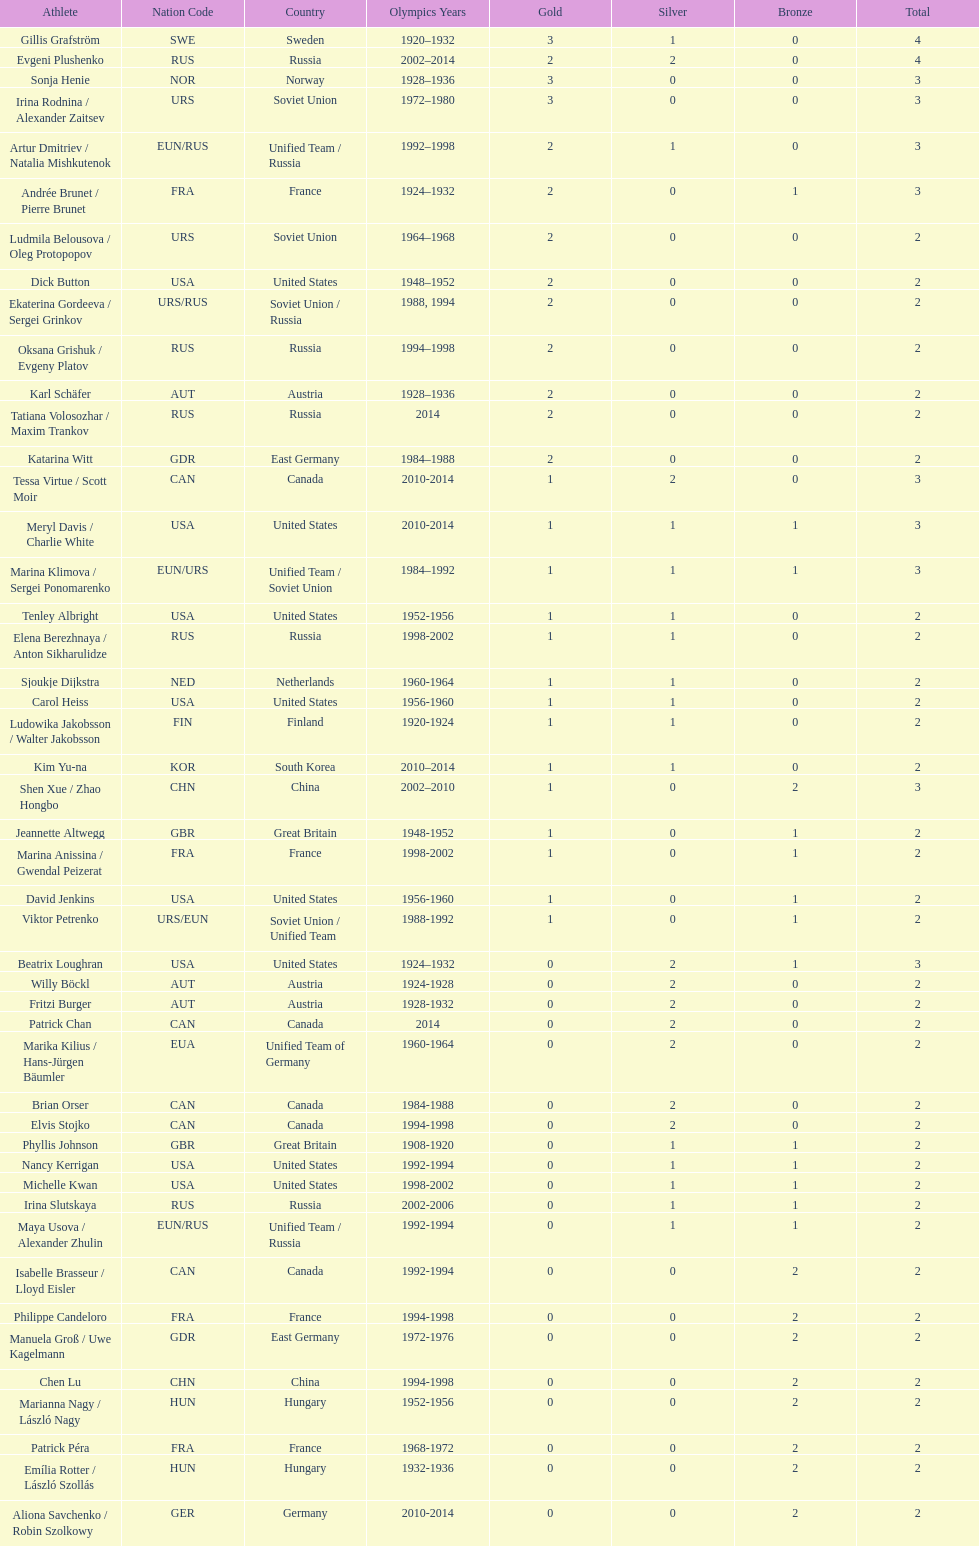What was the greatest number of gold medals won by a single athlete? 3. Could you parse the entire table? {'header': ['Athlete', 'Nation Code', 'Country', 'Olympics Years', 'Gold', 'Silver', 'Bronze', 'Total'], 'rows': [['Gillis Grafström', 'SWE', 'Sweden', '1920–1932', '3', '1', '0', '4'], ['Evgeni Plushenko', 'RUS', 'Russia', '2002–2014', '2', '2', '0', '4'], ['Sonja Henie', 'NOR', 'Norway', '1928–1936', '3', '0', '0', '3'], ['Irina Rodnina / Alexander Zaitsev', 'URS', 'Soviet Union', '1972–1980', '3', '0', '0', '3'], ['Artur Dmitriev / Natalia Mishkutenok', 'EUN/RUS', 'Unified Team / Russia', '1992–1998', '2', '1', '0', '3'], ['Andrée Brunet / Pierre Brunet', 'FRA', 'France', '1924–1932', '2', '0', '1', '3'], ['Ludmila Belousova / Oleg Protopopov', 'URS', 'Soviet Union', '1964–1968', '2', '0', '0', '2'], ['Dick Button', 'USA', 'United States', '1948–1952', '2', '0', '0', '2'], ['Ekaterina Gordeeva / Sergei Grinkov', 'URS/RUS', 'Soviet Union / Russia', '1988, 1994', '2', '0', '0', '2'], ['Oksana Grishuk / Evgeny Platov', 'RUS', 'Russia', '1994–1998', '2', '0', '0', '2'], ['Karl Schäfer', 'AUT', 'Austria', '1928–1936', '2', '0', '0', '2'], ['Tatiana Volosozhar / Maxim Trankov', 'RUS', 'Russia', '2014', '2', '0', '0', '2'], ['Katarina Witt', 'GDR', 'East Germany', '1984–1988', '2', '0', '0', '2'], ['Tessa Virtue / Scott Moir', 'CAN', 'Canada', '2010-2014', '1', '2', '0', '3'], ['Meryl Davis / Charlie White', 'USA', 'United States', '2010-2014', '1', '1', '1', '3'], ['Marina Klimova / Sergei Ponomarenko', 'EUN/URS', 'Unified Team / Soviet Union', '1984–1992', '1', '1', '1', '3'], ['Tenley Albright', 'USA', 'United States', '1952-1956', '1', '1', '0', '2'], ['Elena Berezhnaya / Anton Sikharulidze', 'RUS', 'Russia', '1998-2002', '1', '1', '0', '2'], ['Sjoukje Dijkstra', 'NED', 'Netherlands', '1960-1964', '1', '1', '0', '2'], ['Carol Heiss', 'USA', 'United States', '1956-1960', '1', '1', '0', '2'], ['Ludowika Jakobsson / Walter Jakobsson', 'FIN', 'Finland', '1920-1924', '1', '1', '0', '2'], ['Kim Yu-na', 'KOR', 'South Korea', '2010–2014', '1', '1', '0', '2'], ['Shen Xue / Zhao Hongbo', 'CHN', 'China', '2002–2010', '1', '0', '2', '3'], ['Jeannette Altwegg', 'GBR', 'Great Britain', '1948-1952', '1', '0', '1', '2'], ['Marina Anissina / Gwendal Peizerat', 'FRA', 'France', '1998-2002', '1', '0', '1', '2'], ['David Jenkins', 'USA', 'United States', '1956-1960', '1', '0', '1', '2'], ['Viktor Petrenko', 'URS/EUN', 'Soviet Union / Unified Team', '1988-1992', '1', '0', '1', '2'], ['Beatrix Loughran', 'USA', 'United States', '1924–1932', '0', '2', '1', '3'], ['Willy Böckl', 'AUT', 'Austria', '1924-1928', '0', '2', '0', '2'], ['Fritzi Burger', 'AUT', 'Austria', '1928-1932', '0', '2', '0', '2'], ['Patrick Chan', 'CAN', 'Canada', '2014', '0', '2', '0', '2'], ['Marika Kilius / Hans-Jürgen Bäumler', 'EUA', 'Unified Team of Germany', '1960-1964', '0', '2', '0', '2'], ['Brian Orser', 'CAN', 'Canada', '1984-1988', '0', '2', '0', '2'], ['Elvis Stojko', 'CAN', 'Canada', '1994-1998', '0', '2', '0', '2'], ['Phyllis Johnson', 'GBR', 'Great Britain', '1908-1920', '0', '1', '1', '2'], ['Nancy Kerrigan', 'USA', 'United States', '1992-1994', '0', '1', '1', '2'], ['Michelle Kwan', 'USA', 'United States', '1998-2002', '0', '1', '1', '2'], ['Irina Slutskaya', 'RUS', 'Russia', '2002-2006', '0', '1', '1', '2'], ['Maya Usova / Alexander Zhulin', 'EUN/RUS', 'Unified Team / Russia', '1992-1994', '0', '1', '1', '2'], ['Isabelle Brasseur / Lloyd Eisler', 'CAN', 'Canada', '1992-1994', '0', '0', '2', '2'], ['Philippe Candeloro', 'FRA', 'France', '1994-1998', '0', '0', '2', '2'], ['Manuela Groß / Uwe Kagelmann', 'GDR', 'East Germany', '1972-1976', '0', '0', '2', '2'], ['Chen Lu', 'CHN', 'China', '1994-1998', '0', '0', '2', '2'], ['Marianna Nagy / László Nagy', 'HUN', 'Hungary', '1952-1956', '0', '0', '2', '2'], ['Patrick Péra', 'FRA', 'France', '1968-1972', '0', '0', '2', '2'], ['Emília Rotter / László Szollás', 'HUN', 'Hungary', '1932-1936', '0', '0', '2', '2'], ['Aliona Savchenko / Robin Szolkowy', 'GER', 'Germany', '2010-2014', '0', '0', '2', '2']]} 